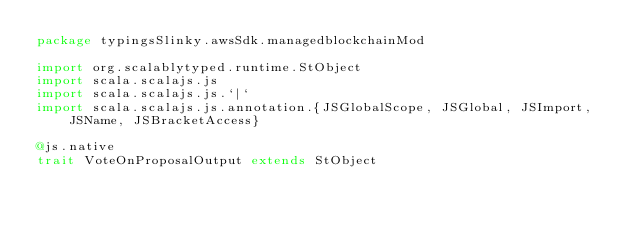Convert code to text. <code><loc_0><loc_0><loc_500><loc_500><_Scala_>package typingsSlinky.awsSdk.managedblockchainMod

import org.scalablytyped.runtime.StObject
import scala.scalajs.js
import scala.scalajs.js.`|`
import scala.scalajs.js.annotation.{JSGlobalScope, JSGlobal, JSImport, JSName, JSBracketAccess}

@js.native
trait VoteOnProposalOutput extends StObject
</code> 